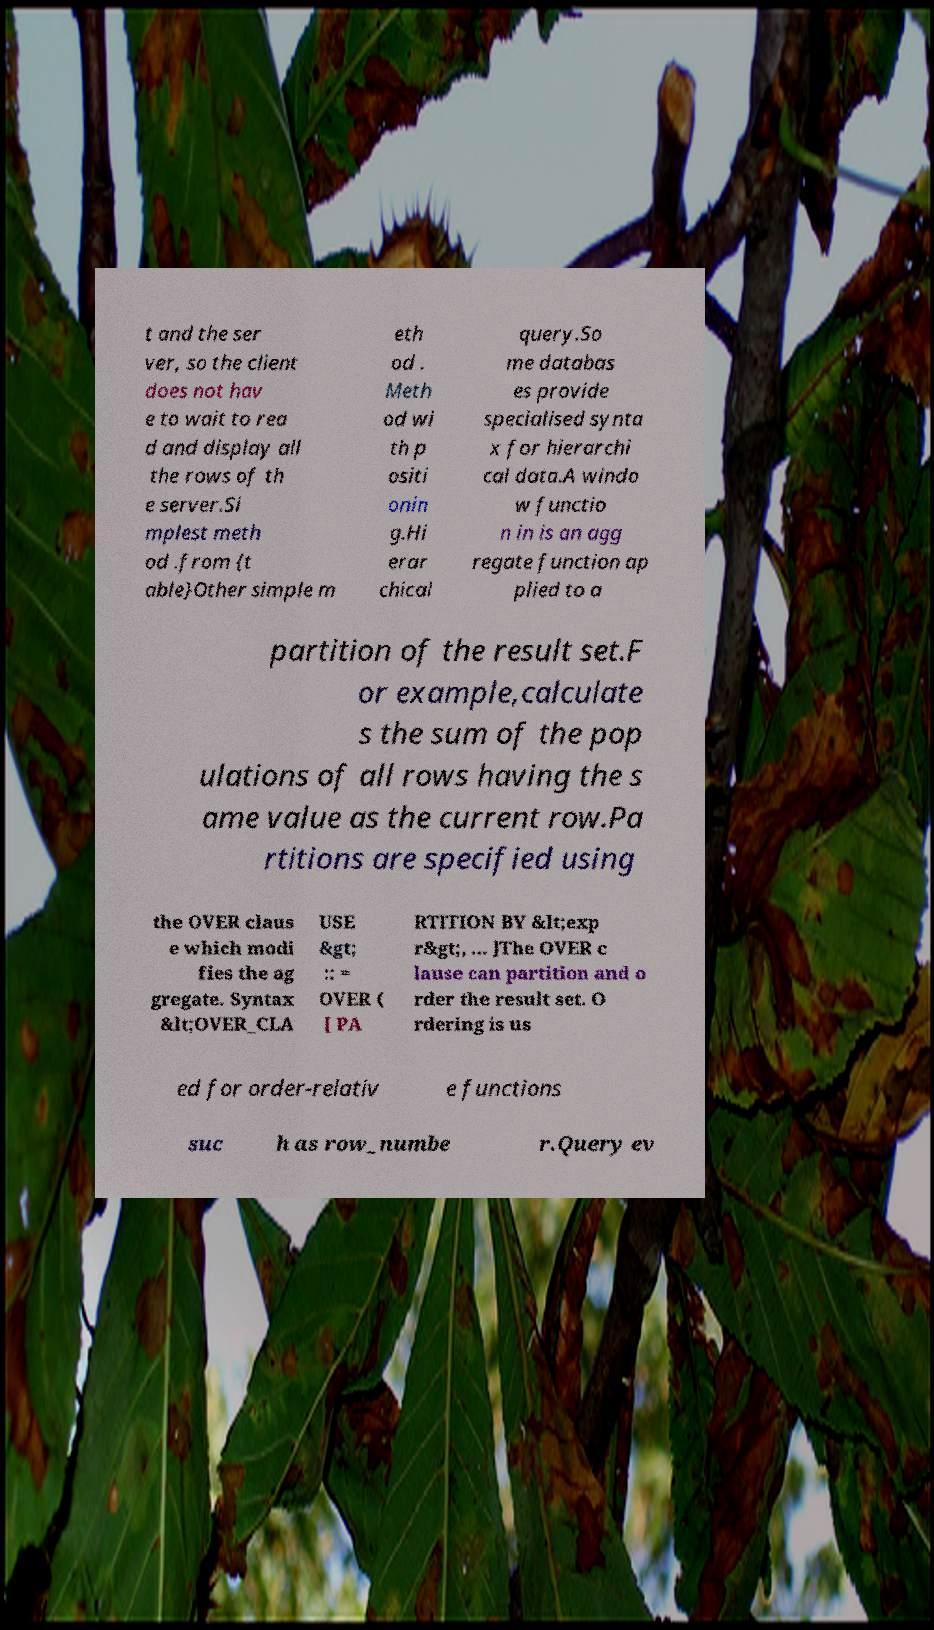Please read and relay the text visible in this image. What does it say? t and the ser ver, so the client does not hav e to wait to rea d and display all the rows of th e server.Si mplest meth od .from {t able}Other simple m eth od . Meth od wi th p ositi onin g.Hi erar chical query.So me databas es provide specialised synta x for hierarchi cal data.A windo w functio n in is an agg regate function ap plied to a partition of the result set.F or example,calculate s the sum of the pop ulations of all rows having the s ame value as the current row.Pa rtitions are specified using the OVER claus e which modi fies the ag gregate. Syntax &lt;OVER_CLA USE &gt; :: = OVER ( [ PA RTITION BY &lt;exp r&gt;, ... ]The OVER c lause can partition and o rder the result set. O rdering is us ed for order-relativ e functions suc h as row_numbe r.Query ev 